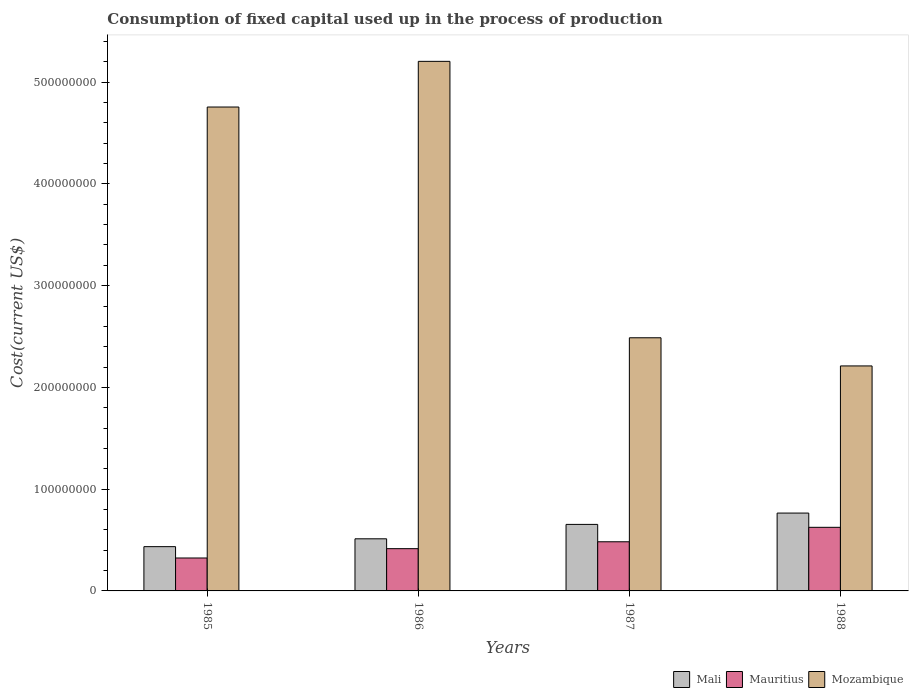How many different coloured bars are there?
Offer a terse response. 3. How many groups of bars are there?
Your answer should be compact. 4. Are the number of bars on each tick of the X-axis equal?
Keep it short and to the point. Yes. How many bars are there on the 1st tick from the left?
Provide a succinct answer. 3. What is the label of the 3rd group of bars from the left?
Provide a succinct answer. 1987. What is the amount consumed in the process of production in Mali in 1986?
Your answer should be compact. 5.12e+07. Across all years, what is the maximum amount consumed in the process of production in Mali?
Offer a terse response. 7.65e+07. Across all years, what is the minimum amount consumed in the process of production in Mali?
Provide a short and direct response. 4.35e+07. In which year was the amount consumed in the process of production in Mali maximum?
Provide a succinct answer. 1988. In which year was the amount consumed in the process of production in Mozambique minimum?
Your response must be concise. 1988. What is the total amount consumed in the process of production in Mali in the graph?
Your answer should be compact. 2.37e+08. What is the difference between the amount consumed in the process of production in Mozambique in 1986 and that in 1987?
Offer a terse response. 2.72e+08. What is the difference between the amount consumed in the process of production in Mauritius in 1986 and the amount consumed in the process of production in Mali in 1985?
Ensure brevity in your answer.  -1.99e+06. What is the average amount consumed in the process of production in Mozambique per year?
Keep it short and to the point. 3.66e+08. In the year 1985, what is the difference between the amount consumed in the process of production in Mali and amount consumed in the process of production in Mauritius?
Keep it short and to the point. 1.12e+07. In how many years, is the amount consumed in the process of production in Mauritius greater than 220000000 US$?
Provide a short and direct response. 0. What is the ratio of the amount consumed in the process of production in Mauritius in 1985 to that in 1988?
Offer a terse response. 0.52. Is the difference between the amount consumed in the process of production in Mali in 1986 and 1988 greater than the difference between the amount consumed in the process of production in Mauritius in 1986 and 1988?
Make the answer very short. No. What is the difference between the highest and the second highest amount consumed in the process of production in Mozambique?
Offer a very short reply. 4.49e+07. What is the difference between the highest and the lowest amount consumed in the process of production in Mauritius?
Your answer should be compact. 3.02e+07. In how many years, is the amount consumed in the process of production in Mauritius greater than the average amount consumed in the process of production in Mauritius taken over all years?
Your response must be concise. 2. What does the 3rd bar from the left in 1985 represents?
Offer a terse response. Mozambique. What does the 2nd bar from the right in 1986 represents?
Provide a succinct answer. Mauritius. Is it the case that in every year, the sum of the amount consumed in the process of production in Mauritius and amount consumed in the process of production in Mozambique is greater than the amount consumed in the process of production in Mali?
Your answer should be very brief. Yes. How many bars are there?
Your answer should be compact. 12. What is the difference between two consecutive major ticks on the Y-axis?
Keep it short and to the point. 1.00e+08. Are the values on the major ticks of Y-axis written in scientific E-notation?
Offer a terse response. No. Does the graph contain any zero values?
Offer a terse response. No. Does the graph contain grids?
Keep it short and to the point. No. Where does the legend appear in the graph?
Offer a terse response. Bottom right. How many legend labels are there?
Provide a succinct answer. 3. How are the legend labels stacked?
Provide a short and direct response. Horizontal. What is the title of the graph?
Offer a terse response. Consumption of fixed capital used up in the process of production. Does "Sri Lanka" appear as one of the legend labels in the graph?
Provide a short and direct response. No. What is the label or title of the Y-axis?
Make the answer very short. Cost(current US$). What is the Cost(current US$) of Mali in 1985?
Provide a short and direct response. 4.35e+07. What is the Cost(current US$) in Mauritius in 1985?
Your answer should be compact. 3.24e+07. What is the Cost(current US$) in Mozambique in 1985?
Ensure brevity in your answer.  4.76e+08. What is the Cost(current US$) in Mali in 1986?
Provide a short and direct response. 5.12e+07. What is the Cost(current US$) of Mauritius in 1986?
Your response must be concise. 4.15e+07. What is the Cost(current US$) in Mozambique in 1986?
Offer a very short reply. 5.20e+08. What is the Cost(current US$) of Mali in 1987?
Offer a terse response. 6.54e+07. What is the Cost(current US$) of Mauritius in 1987?
Give a very brief answer. 4.83e+07. What is the Cost(current US$) of Mozambique in 1987?
Ensure brevity in your answer.  2.49e+08. What is the Cost(current US$) in Mali in 1988?
Offer a very short reply. 7.65e+07. What is the Cost(current US$) in Mauritius in 1988?
Make the answer very short. 6.25e+07. What is the Cost(current US$) of Mozambique in 1988?
Offer a terse response. 2.21e+08. Across all years, what is the maximum Cost(current US$) in Mali?
Provide a short and direct response. 7.65e+07. Across all years, what is the maximum Cost(current US$) in Mauritius?
Provide a succinct answer. 6.25e+07. Across all years, what is the maximum Cost(current US$) in Mozambique?
Provide a short and direct response. 5.20e+08. Across all years, what is the minimum Cost(current US$) in Mali?
Your answer should be compact. 4.35e+07. Across all years, what is the minimum Cost(current US$) in Mauritius?
Your answer should be very brief. 3.24e+07. Across all years, what is the minimum Cost(current US$) in Mozambique?
Offer a very short reply. 2.21e+08. What is the total Cost(current US$) in Mali in the graph?
Offer a terse response. 2.37e+08. What is the total Cost(current US$) in Mauritius in the graph?
Provide a succinct answer. 1.85e+08. What is the total Cost(current US$) of Mozambique in the graph?
Your response must be concise. 1.47e+09. What is the difference between the Cost(current US$) in Mali in 1985 and that in 1986?
Give a very brief answer. -7.70e+06. What is the difference between the Cost(current US$) in Mauritius in 1985 and that in 1986?
Make the answer very short. -9.17e+06. What is the difference between the Cost(current US$) in Mozambique in 1985 and that in 1986?
Ensure brevity in your answer.  -4.49e+07. What is the difference between the Cost(current US$) in Mali in 1985 and that in 1987?
Keep it short and to the point. -2.19e+07. What is the difference between the Cost(current US$) in Mauritius in 1985 and that in 1987?
Your answer should be very brief. -1.60e+07. What is the difference between the Cost(current US$) of Mozambique in 1985 and that in 1987?
Offer a terse response. 2.27e+08. What is the difference between the Cost(current US$) in Mali in 1985 and that in 1988?
Your answer should be compact. -3.30e+07. What is the difference between the Cost(current US$) in Mauritius in 1985 and that in 1988?
Ensure brevity in your answer.  -3.02e+07. What is the difference between the Cost(current US$) in Mozambique in 1985 and that in 1988?
Provide a succinct answer. 2.54e+08. What is the difference between the Cost(current US$) of Mali in 1986 and that in 1987?
Provide a succinct answer. -1.42e+07. What is the difference between the Cost(current US$) in Mauritius in 1986 and that in 1987?
Make the answer very short. -6.78e+06. What is the difference between the Cost(current US$) in Mozambique in 1986 and that in 1987?
Ensure brevity in your answer.  2.72e+08. What is the difference between the Cost(current US$) of Mali in 1986 and that in 1988?
Make the answer very short. -2.53e+07. What is the difference between the Cost(current US$) in Mauritius in 1986 and that in 1988?
Your answer should be compact. -2.10e+07. What is the difference between the Cost(current US$) of Mozambique in 1986 and that in 1988?
Your response must be concise. 2.99e+08. What is the difference between the Cost(current US$) of Mali in 1987 and that in 1988?
Offer a very short reply. -1.11e+07. What is the difference between the Cost(current US$) in Mauritius in 1987 and that in 1988?
Offer a very short reply. -1.42e+07. What is the difference between the Cost(current US$) in Mozambique in 1987 and that in 1988?
Provide a succinct answer. 2.77e+07. What is the difference between the Cost(current US$) of Mali in 1985 and the Cost(current US$) of Mauritius in 1986?
Make the answer very short. 1.99e+06. What is the difference between the Cost(current US$) of Mali in 1985 and the Cost(current US$) of Mozambique in 1986?
Offer a very short reply. -4.77e+08. What is the difference between the Cost(current US$) of Mauritius in 1985 and the Cost(current US$) of Mozambique in 1986?
Offer a very short reply. -4.88e+08. What is the difference between the Cost(current US$) of Mali in 1985 and the Cost(current US$) of Mauritius in 1987?
Your response must be concise. -4.79e+06. What is the difference between the Cost(current US$) of Mali in 1985 and the Cost(current US$) of Mozambique in 1987?
Your answer should be compact. -2.05e+08. What is the difference between the Cost(current US$) in Mauritius in 1985 and the Cost(current US$) in Mozambique in 1987?
Ensure brevity in your answer.  -2.16e+08. What is the difference between the Cost(current US$) of Mali in 1985 and the Cost(current US$) of Mauritius in 1988?
Your answer should be very brief. -1.90e+07. What is the difference between the Cost(current US$) in Mali in 1985 and the Cost(current US$) in Mozambique in 1988?
Offer a terse response. -1.78e+08. What is the difference between the Cost(current US$) in Mauritius in 1985 and the Cost(current US$) in Mozambique in 1988?
Your answer should be compact. -1.89e+08. What is the difference between the Cost(current US$) of Mali in 1986 and the Cost(current US$) of Mauritius in 1987?
Provide a succinct answer. 2.91e+06. What is the difference between the Cost(current US$) of Mali in 1986 and the Cost(current US$) of Mozambique in 1987?
Provide a succinct answer. -1.98e+08. What is the difference between the Cost(current US$) of Mauritius in 1986 and the Cost(current US$) of Mozambique in 1987?
Offer a very short reply. -2.07e+08. What is the difference between the Cost(current US$) in Mali in 1986 and the Cost(current US$) in Mauritius in 1988?
Offer a terse response. -1.13e+07. What is the difference between the Cost(current US$) in Mali in 1986 and the Cost(current US$) in Mozambique in 1988?
Keep it short and to the point. -1.70e+08. What is the difference between the Cost(current US$) of Mauritius in 1986 and the Cost(current US$) of Mozambique in 1988?
Offer a terse response. -1.80e+08. What is the difference between the Cost(current US$) of Mali in 1987 and the Cost(current US$) of Mauritius in 1988?
Make the answer very short. 2.86e+06. What is the difference between the Cost(current US$) in Mali in 1987 and the Cost(current US$) in Mozambique in 1988?
Make the answer very short. -1.56e+08. What is the difference between the Cost(current US$) in Mauritius in 1987 and the Cost(current US$) in Mozambique in 1988?
Provide a short and direct response. -1.73e+08. What is the average Cost(current US$) of Mali per year?
Your answer should be very brief. 5.92e+07. What is the average Cost(current US$) of Mauritius per year?
Make the answer very short. 4.62e+07. What is the average Cost(current US$) of Mozambique per year?
Your answer should be very brief. 3.66e+08. In the year 1985, what is the difference between the Cost(current US$) of Mali and Cost(current US$) of Mauritius?
Make the answer very short. 1.12e+07. In the year 1985, what is the difference between the Cost(current US$) of Mali and Cost(current US$) of Mozambique?
Keep it short and to the point. -4.32e+08. In the year 1985, what is the difference between the Cost(current US$) in Mauritius and Cost(current US$) in Mozambique?
Offer a terse response. -4.43e+08. In the year 1986, what is the difference between the Cost(current US$) in Mali and Cost(current US$) in Mauritius?
Your answer should be very brief. 9.69e+06. In the year 1986, what is the difference between the Cost(current US$) of Mali and Cost(current US$) of Mozambique?
Offer a very short reply. -4.69e+08. In the year 1986, what is the difference between the Cost(current US$) of Mauritius and Cost(current US$) of Mozambique?
Make the answer very short. -4.79e+08. In the year 1987, what is the difference between the Cost(current US$) in Mali and Cost(current US$) in Mauritius?
Make the answer very short. 1.71e+07. In the year 1987, what is the difference between the Cost(current US$) in Mali and Cost(current US$) in Mozambique?
Keep it short and to the point. -1.83e+08. In the year 1987, what is the difference between the Cost(current US$) in Mauritius and Cost(current US$) in Mozambique?
Keep it short and to the point. -2.00e+08. In the year 1988, what is the difference between the Cost(current US$) of Mali and Cost(current US$) of Mauritius?
Provide a short and direct response. 1.40e+07. In the year 1988, what is the difference between the Cost(current US$) in Mali and Cost(current US$) in Mozambique?
Offer a terse response. -1.45e+08. In the year 1988, what is the difference between the Cost(current US$) of Mauritius and Cost(current US$) of Mozambique?
Provide a succinct answer. -1.59e+08. What is the ratio of the Cost(current US$) in Mali in 1985 to that in 1986?
Give a very brief answer. 0.85. What is the ratio of the Cost(current US$) in Mauritius in 1985 to that in 1986?
Your answer should be compact. 0.78. What is the ratio of the Cost(current US$) in Mozambique in 1985 to that in 1986?
Offer a very short reply. 0.91. What is the ratio of the Cost(current US$) in Mali in 1985 to that in 1987?
Ensure brevity in your answer.  0.67. What is the ratio of the Cost(current US$) in Mauritius in 1985 to that in 1987?
Your answer should be compact. 0.67. What is the ratio of the Cost(current US$) in Mozambique in 1985 to that in 1987?
Offer a very short reply. 1.91. What is the ratio of the Cost(current US$) in Mali in 1985 to that in 1988?
Give a very brief answer. 0.57. What is the ratio of the Cost(current US$) in Mauritius in 1985 to that in 1988?
Offer a very short reply. 0.52. What is the ratio of the Cost(current US$) in Mozambique in 1985 to that in 1988?
Offer a terse response. 2.15. What is the ratio of the Cost(current US$) of Mali in 1986 to that in 1987?
Your answer should be compact. 0.78. What is the ratio of the Cost(current US$) in Mauritius in 1986 to that in 1987?
Offer a terse response. 0.86. What is the ratio of the Cost(current US$) in Mozambique in 1986 to that in 1987?
Provide a succinct answer. 2.09. What is the ratio of the Cost(current US$) in Mali in 1986 to that in 1988?
Offer a terse response. 0.67. What is the ratio of the Cost(current US$) of Mauritius in 1986 to that in 1988?
Offer a terse response. 0.66. What is the ratio of the Cost(current US$) of Mozambique in 1986 to that in 1988?
Your response must be concise. 2.35. What is the ratio of the Cost(current US$) in Mali in 1987 to that in 1988?
Your answer should be very brief. 0.85. What is the ratio of the Cost(current US$) in Mauritius in 1987 to that in 1988?
Make the answer very short. 0.77. What is the ratio of the Cost(current US$) of Mozambique in 1987 to that in 1988?
Your response must be concise. 1.13. What is the difference between the highest and the second highest Cost(current US$) of Mali?
Your answer should be very brief. 1.11e+07. What is the difference between the highest and the second highest Cost(current US$) of Mauritius?
Provide a succinct answer. 1.42e+07. What is the difference between the highest and the second highest Cost(current US$) in Mozambique?
Your answer should be compact. 4.49e+07. What is the difference between the highest and the lowest Cost(current US$) of Mali?
Ensure brevity in your answer.  3.30e+07. What is the difference between the highest and the lowest Cost(current US$) in Mauritius?
Provide a short and direct response. 3.02e+07. What is the difference between the highest and the lowest Cost(current US$) in Mozambique?
Make the answer very short. 2.99e+08. 